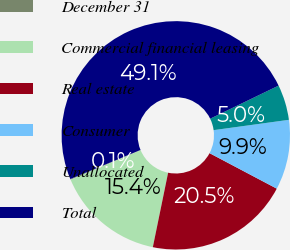Convert chart. <chart><loc_0><loc_0><loc_500><loc_500><pie_chart><fcel>December 31<fcel>Commercial financial leasing<fcel>Real estate<fcel>Consumer<fcel>Unallocated<fcel>Total<nl><fcel>0.1%<fcel>15.42%<fcel>20.49%<fcel>9.9%<fcel>5.0%<fcel>49.08%<nl></chart> 